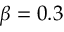<formula> <loc_0><loc_0><loc_500><loc_500>\beta = 0 . 3</formula> 